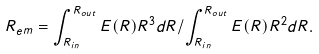Convert formula to latex. <formula><loc_0><loc_0><loc_500><loc_500>R _ { e m } = \int _ { R _ { i n } } ^ { R _ { o u t } } E ( R ) R ^ { 3 } d R / \int _ { R _ { i n } } ^ { R _ { o u t } } E ( R ) R ^ { 2 } d R .</formula> 